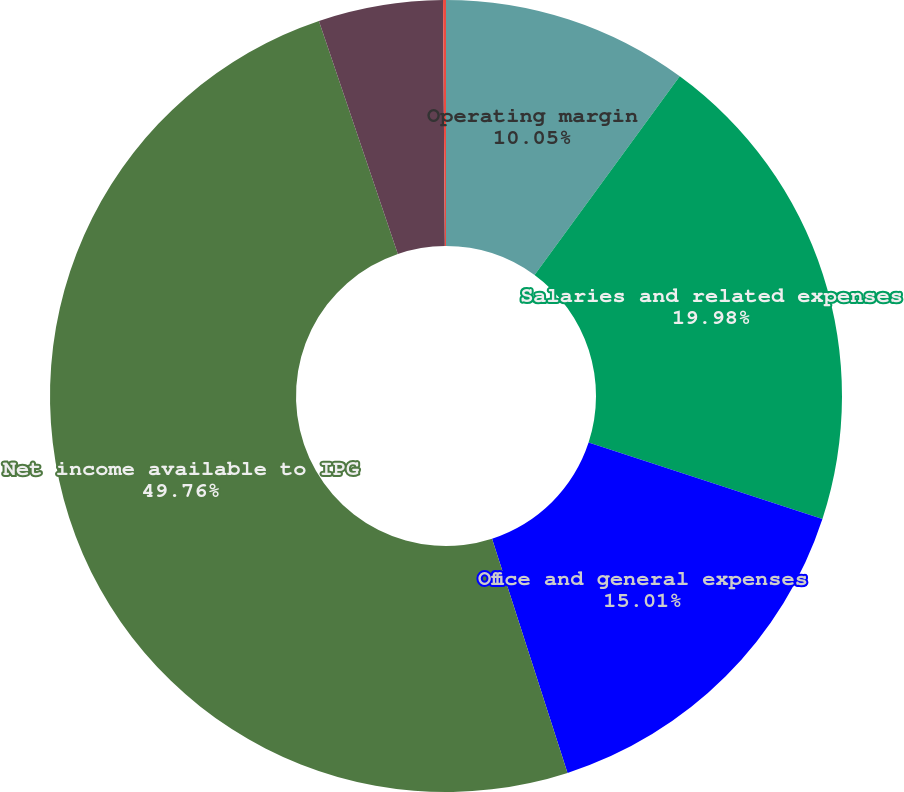Convert chart. <chart><loc_0><loc_0><loc_500><loc_500><pie_chart><fcel>Operating margin<fcel>Salaries and related expenses<fcel>Office and general expenses<fcel>Net income available to IPG<fcel>Basic<fcel>Diluted<nl><fcel>10.05%<fcel>19.98%<fcel>15.01%<fcel>49.77%<fcel>5.08%<fcel>0.12%<nl></chart> 